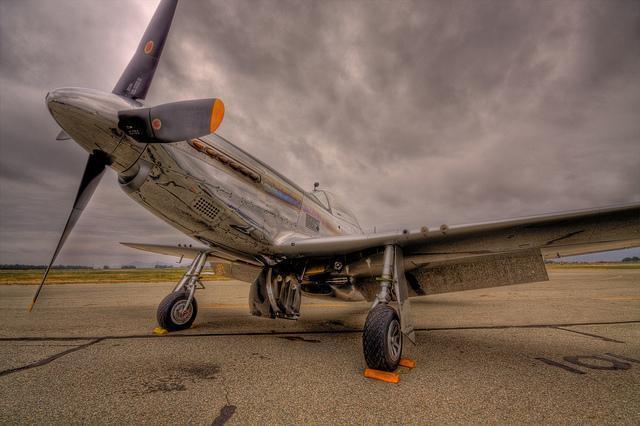How many of the people in the picture are wearing pants?
Give a very brief answer. 0. 